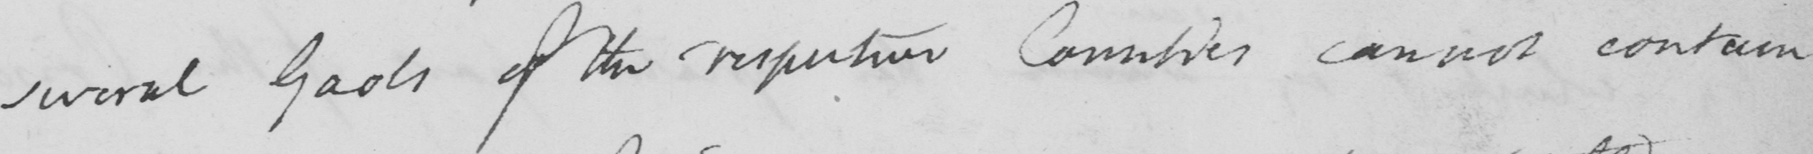What does this handwritten line say? several Gaols of the respective Counties cannot contain, 